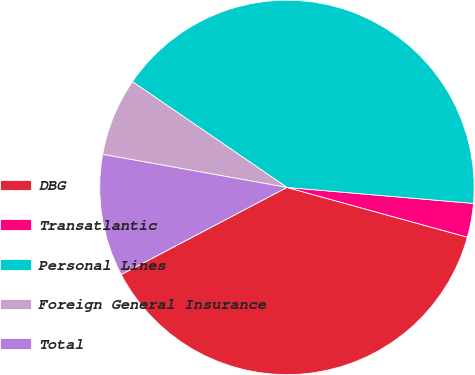Convert chart to OTSL. <chart><loc_0><loc_0><loc_500><loc_500><pie_chart><fcel>DBG<fcel>Transatlantic<fcel>Personal Lines<fcel>Foreign General Insurance<fcel>Total<nl><fcel>38.01%<fcel>2.92%<fcel>41.81%<fcel>6.73%<fcel>10.53%<nl></chart> 